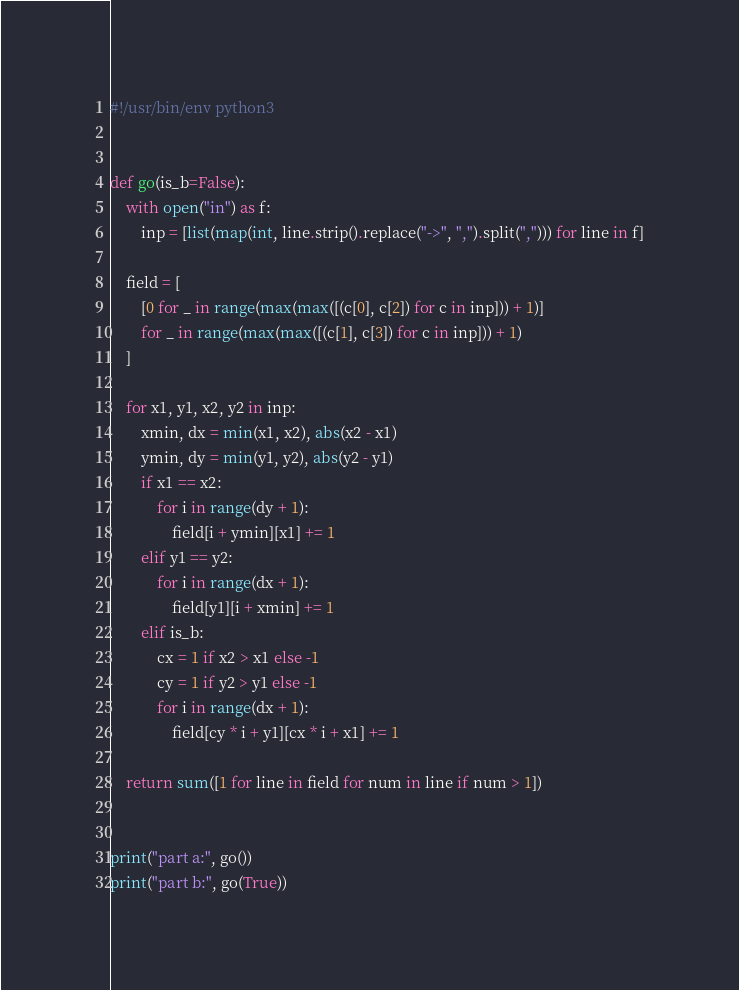Convert code to text. <code><loc_0><loc_0><loc_500><loc_500><_Python_>#!/usr/bin/env python3


def go(is_b=False):
    with open("in") as f:
        inp = [list(map(int, line.strip().replace("->", ",").split(","))) for line in f]

    field = [
        [0 for _ in range(max(max([(c[0], c[2]) for c in inp])) + 1)]
        for _ in range(max(max([(c[1], c[3]) for c in inp])) + 1)
    ]

    for x1, y1, x2, y2 in inp:
        xmin, dx = min(x1, x2), abs(x2 - x1)
        ymin, dy = min(y1, y2), abs(y2 - y1)
        if x1 == x2:
            for i in range(dy + 1):
                field[i + ymin][x1] += 1
        elif y1 == y2:
            for i in range(dx + 1):
                field[y1][i + xmin] += 1
        elif is_b:
            cx = 1 if x2 > x1 else -1
            cy = 1 if y2 > y1 else -1
            for i in range(dx + 1):
                field[cy * i + y1][cx * i + x1] += 1

    return sum([1 for line in field for num in line if num > 1])


print("part a:", go())
print("part b:", go(True))
</code> 